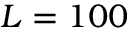<formula> <loc_0><loc_0><loc_500><loc_500>L = 1 0 0</formula> 